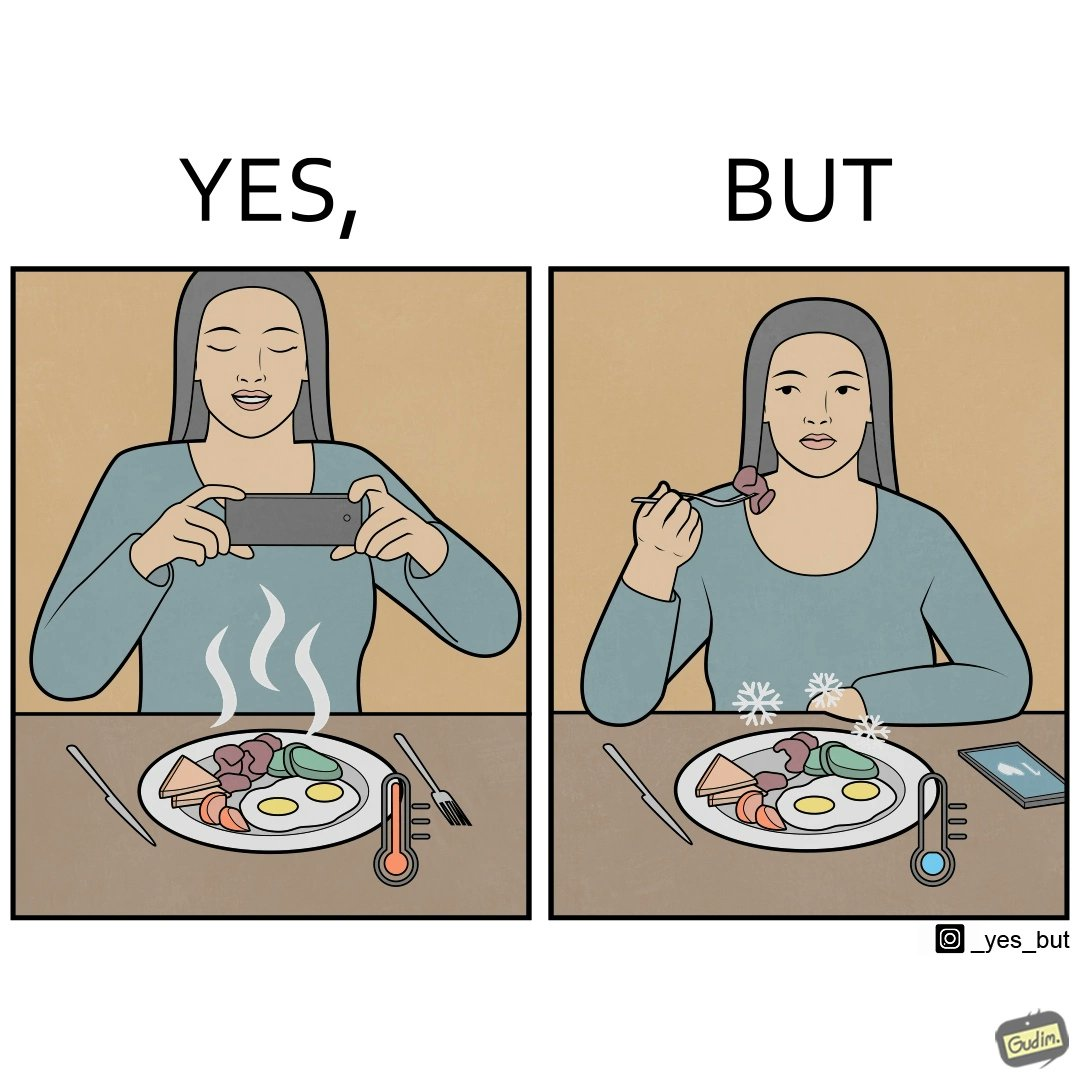What is shown in the left half versus the right half of this image? In the left part of the image: It is a woman taking pictures of her food In the right part of the image: It is a woman eating cold food 